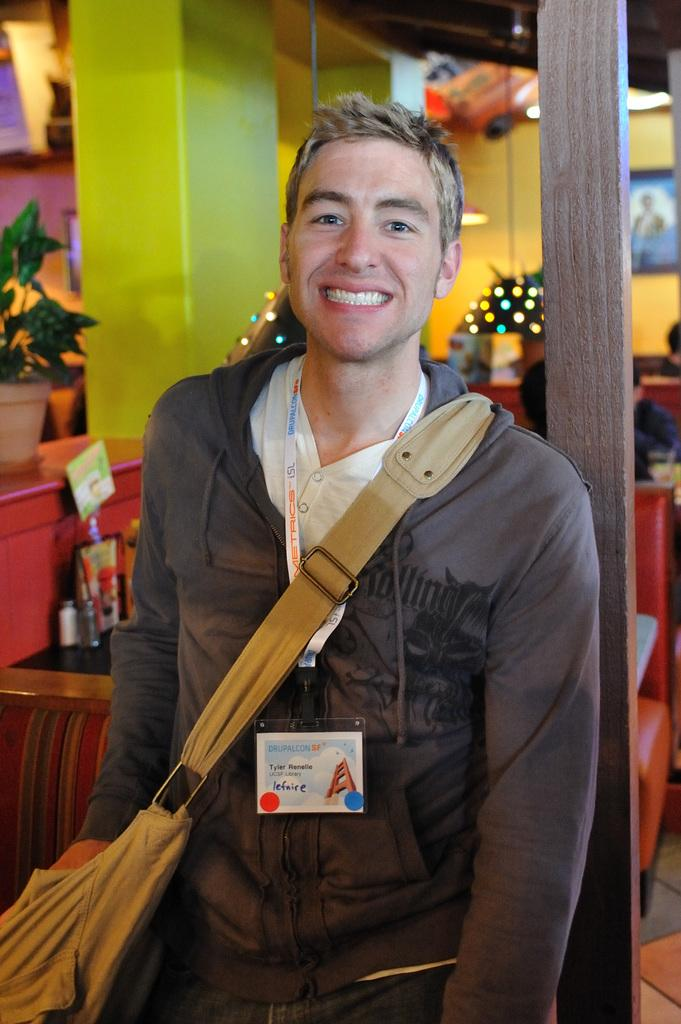What is the person in the image wearing on their body? The person in the image is wearing a bag. What is the position of the person in the image? The person is standing. What are the people in the image doing? The people in the image are sitting on couches. How are the tables arranged in the image? Tables are arranged in the image. What type of vegetation can be seen in the image? There are potted plants in the image. What type of pollution can be seen in the image? There is no pollution visible in the image. How many bulbs are present in the image? There is no mention of bulbs in the image. 